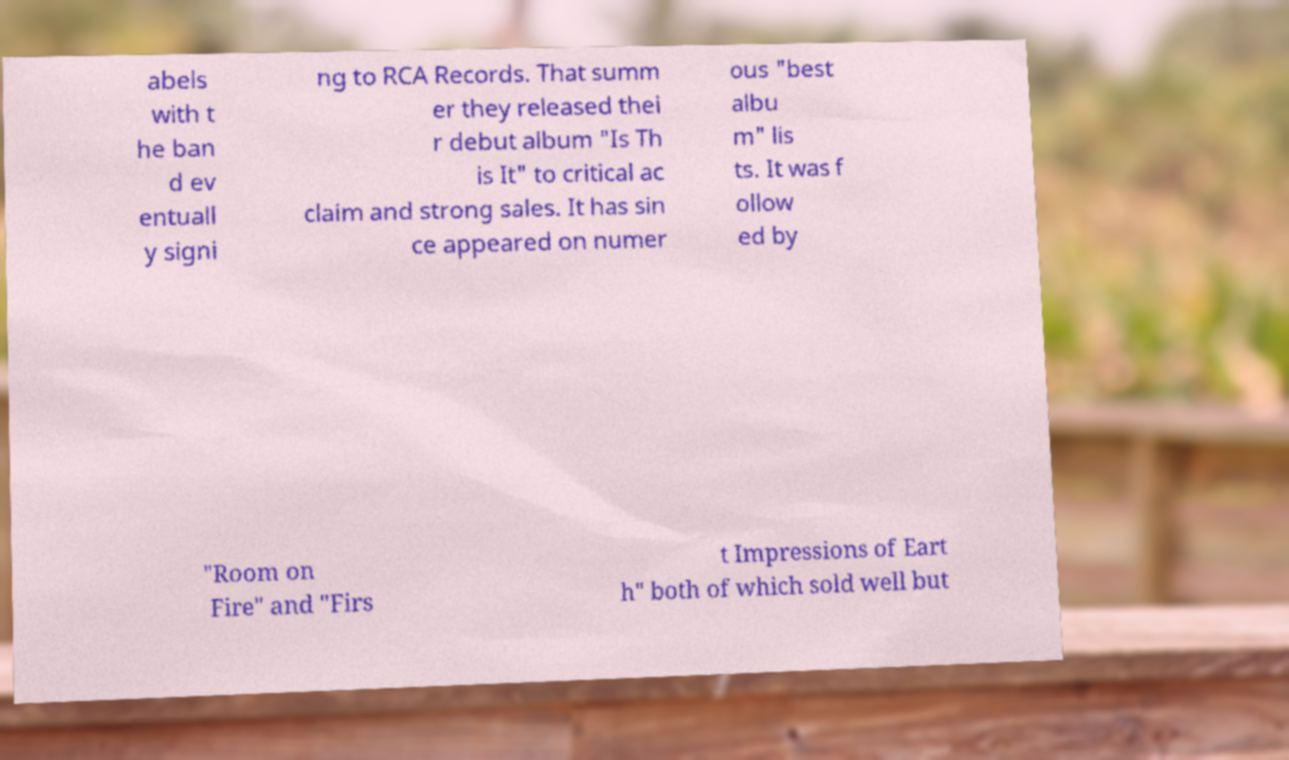Can you read and provide the text displayed in the image?This photo seems to have some interesting text. Can you extract and type it out for me? abels with t he ban d ev entuall y signi ng to RCA Records. That summ er they released thei r debut album "Is Th is It" to critical ac claim and strong sales. It has sin ce appeared on numer ous "best albu m" lis ts. It was f ollow ed by "Room on Fire" and "Firs t Impressions of Eart h" both of which sold well but 